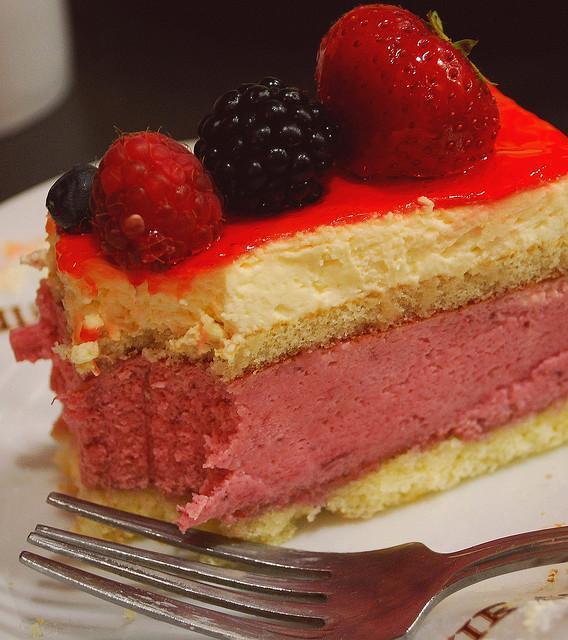How many layers is the cake?
Give a very brief answer. 3. How many cherries are there?
Give a very brief answer. 0. How many forks can be seen?
Give a very brief answer. 1. How many people are to the left of the man with an umbrella over his head?
Give a very brief answer. 0. 